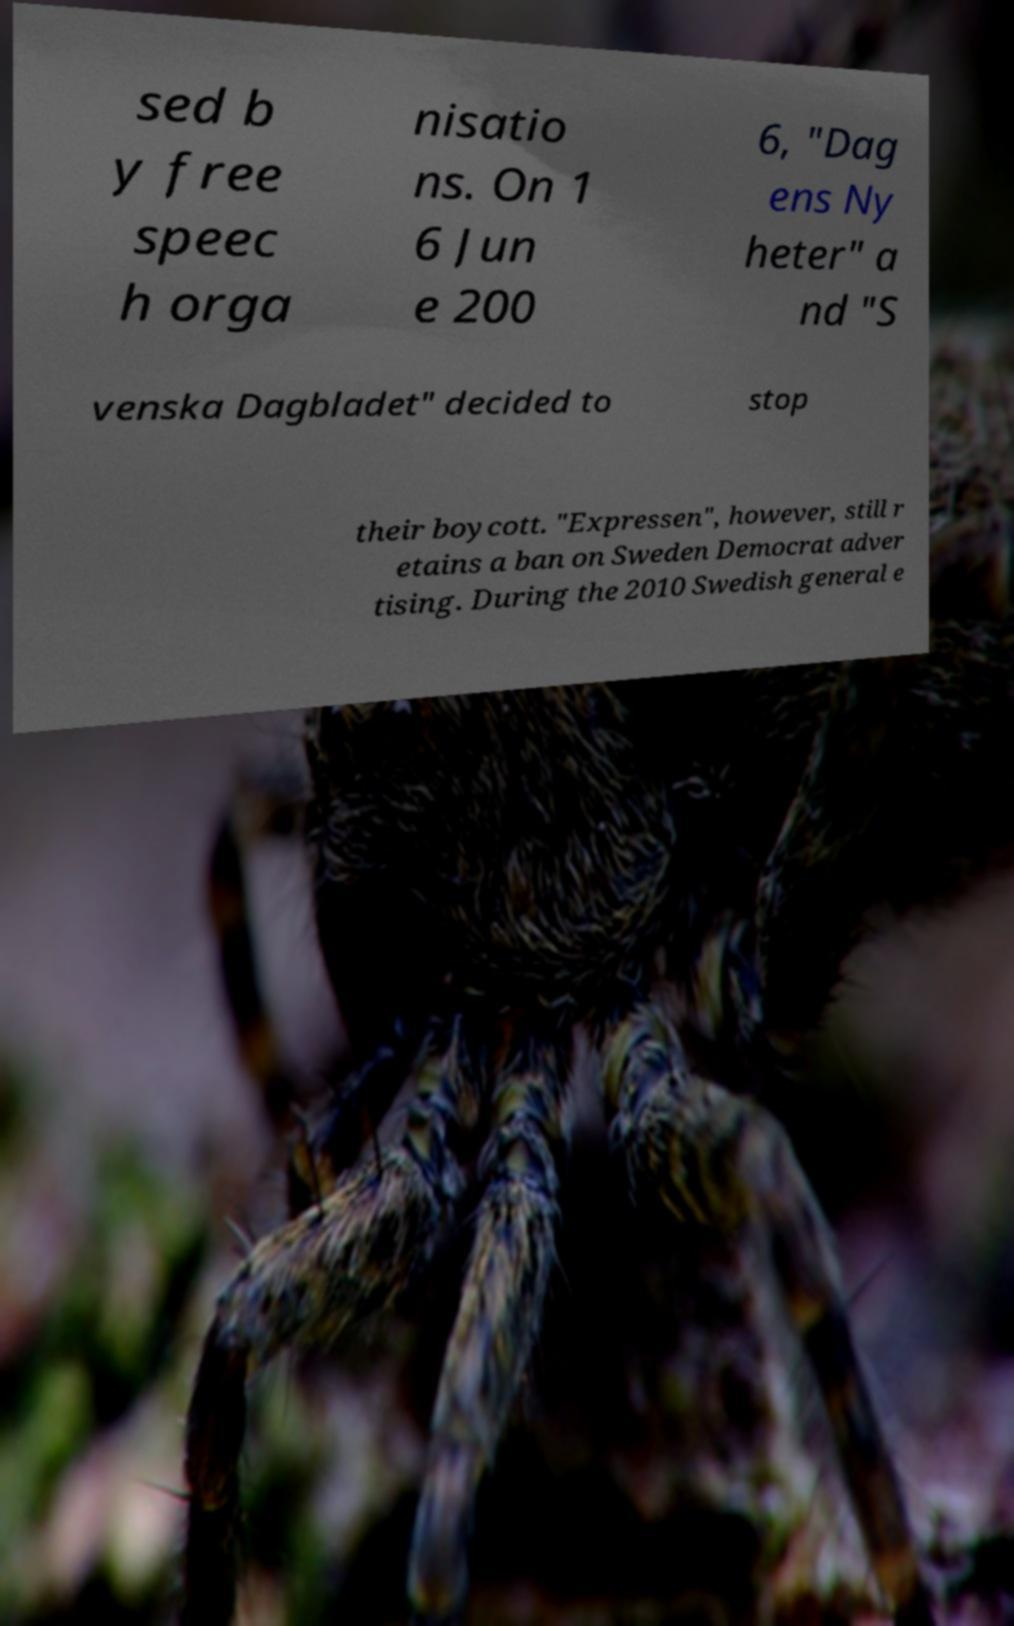For documentation purposes, I need the text within this image transcribed. Could you provide that? sed b y free speec h orga nisatio ns. On 1 6 Jun e 200 6, "Dag ens Ny heter" a nd "S venska Dagbladet" decided to stop their boycott. "Expressen", however, still r etains a ban on Sweden Democrat adver tising. During the 2010 Swedish general e 